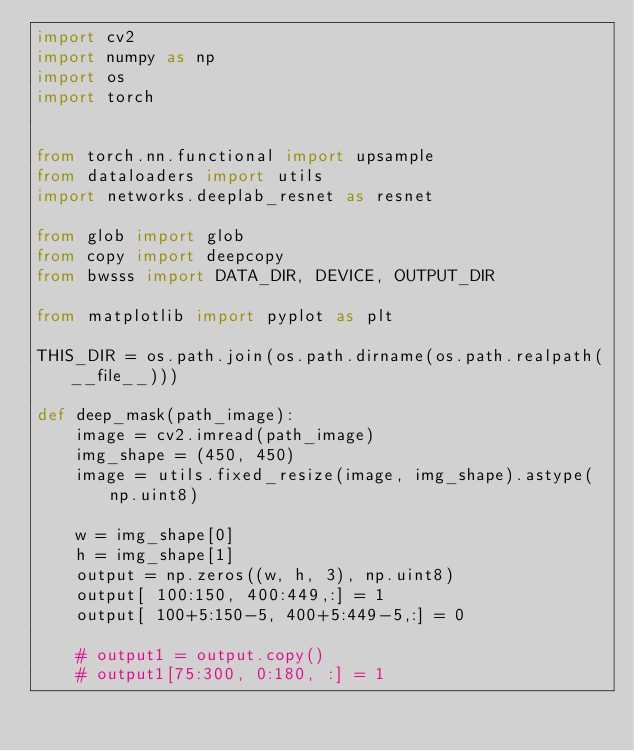Convert code to text. <code><loc_0><loc_0><loc_500><loc_500><_Python_>import cv2
import numpy as np
import os
import torch


from torch.nn.functional import upsample
from dataloaders import utils
import networks.deeplab_resnet as resnet

from glob import glob
from copy import deepcopy
from bwsss import DATA_DIR, DEVICE, OUTPUT_DIR

from matplotlib import pyplot as plt

THIS_DIR = os.path.join(os.path.dirname(os.path.realpath(__file__)))

def deep_mask(path_image):
    image = cv2.imread(path_image)
    img_shape = (450, 450)
    image = utils.fixed_resize(image, img_shape).astype(np.uint8)

    w = img_shape[0]
    h = img_shape[1]
    output = np.zeros((w, h, 3), np.uint8)
    output[ 100:150, 400:449,:] = 1
    output[ 100+5:150-5, 400+5:449-5,:] = 0

    # output1 = output.copy()
    # output1[75:300, 0:180, :] = 1</code> 